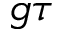<formula> <loc_0><loc_0><loc_500><loc_500>g \tau</formula> 